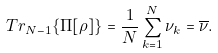<formula> <loc_0><loc_0><loc_500><loc_500>T r _ { N - 1 } \{ \Pi [ \rho ] \} = \frac { 1 } { N } \sum _ { k = 1 } ^ { N } \nu _ { k } = \overline { \nu } .</formula> 